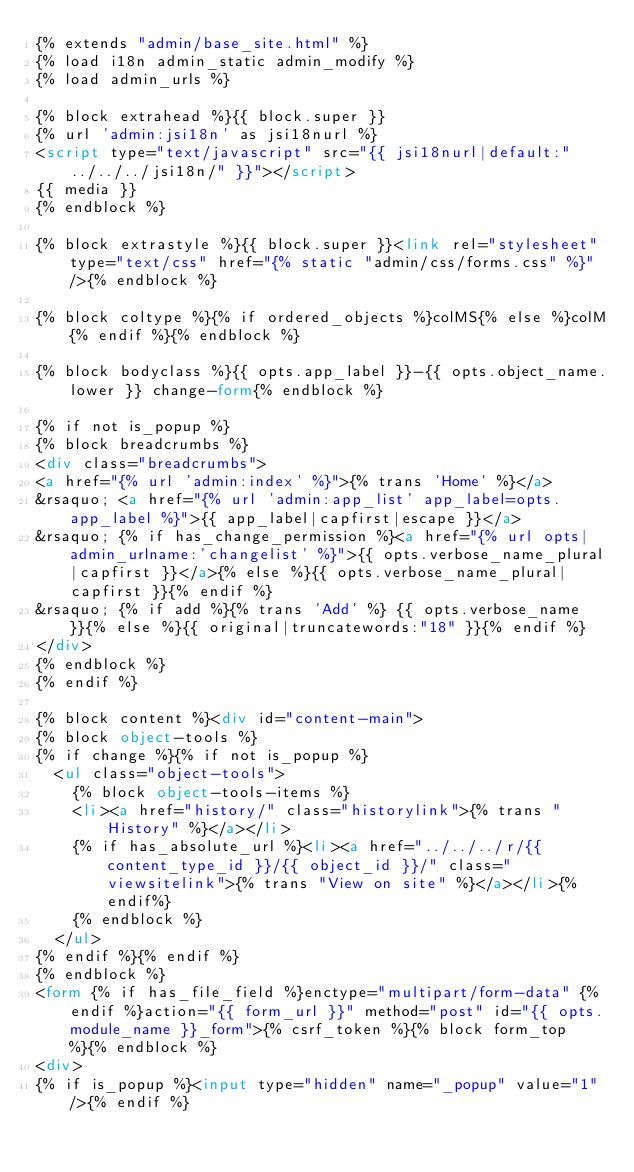<code> <loc_0><loc_0><loc_500><loc_500><_HTML_>{% extends "admin/base_site.html" %}
{% load i18n admin_static admin_modify %}
{% load admin_urls %}

{% block extrahead %}{{ block.super }}
{% url 'admin:jsi18n' as jsi18nurl %}
<script type="text/javascript" src="{{ jsi18nurl|default:"../../../jsi18n/" }}"></script>
{{ media }}
{% endblock %}

{% block extrastyle %}{{ block.super }}<link rel="stylesheet" type="text/css" href="{% static "admin/css/forms.css" %}" />{% endblock %}

{% block coltype %}{% if ordered_objects %}colMS{% else %}colM{% endif %}{% endblock %}

{% block bodyclass %}{{ opts.app_label }}-{{ opts.object_name.lower }} change-form{% endblock %}

{% if not is_popup %}
{% block breadcrumbs %}
<div class="breadcrumbs">
<a href="{% url 'admin:index' %}">{% trans 'Home' %}</a>
&rsaquo; <a href="{% url 'admin:app_list' app_label=opts.app_label %}">{{ app_label|capfirst|escape }}</a>
&rsaquo; {% if has_change_permission %}<a href="{% url opts|admin_urlname:'changelist' %}">{{ opts.verbose_name_plural|capfirst }}</a>{% else %}{{ opts.verbose_name_plural|capfirst }}{% endif %}
&rsaquo; {% if add %}{% trans 'Add' %} {{ opts.verbose_name }}{% else %}{{ original|truncatewords:"18" }}{% endif %}
</div>
{% endblock %}
{% endif %}

{% block content %}<div id="content-main">
{% block object-tools %}
{% if change %}{% if not is_popup %}
  <ul class="object-tools">
    {% block object-tools-items %}
    <li><a href="history/" class="historylink">{% trans "History" %}</a></li>
    {% if has_absolute_url %}<li><a href="../../../r/{{ content_type_id }}/{{ object_id }}/" class="viewsitelink">{% trans "View on site" %}</a></li>{% endif%}
    {% endblock %}
  </ul>
{% endif %}{% endif %}
{% endblock %}
<form {% if has_file_field %}enctype="multipart/form-data" {% endif %}action="{{ form_url }}" method="post" id="{{ opts.module_name }}_form">{% csrf_token %}{% block form_top %}{% endblock %}
<div>
{% if is_popup %}<input type="hidden" name="_popup" value="1" />{% endif %}</code> 